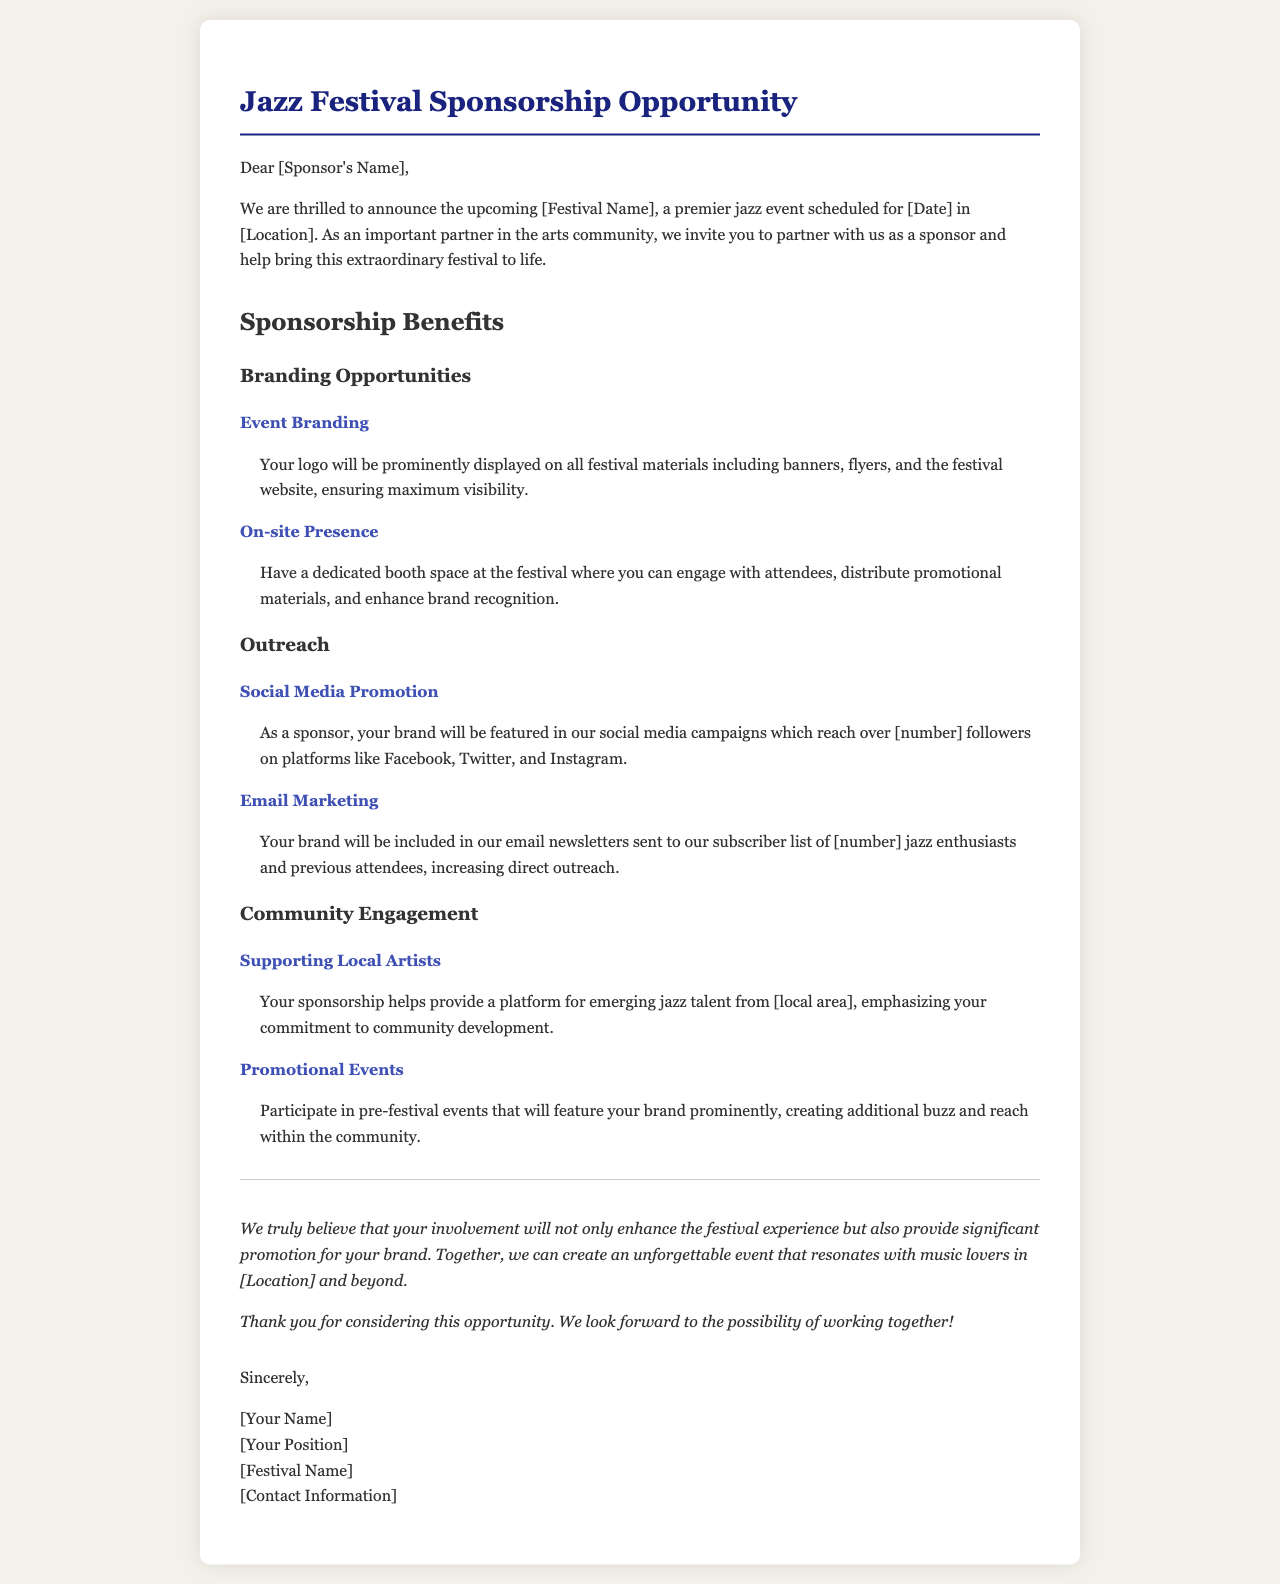What is the title of the document? The title of the document can be found in the header section, which indicates the purpose of the letter.
Answer: Jazz Festival Sponsorship Opportunity What is the date of the festival? The date is mentioned specifically in the opening paragraph inviting sponsorship.
Answer: [Date] What is one benefit of event branding for sponsors? The document outlines various benefits, highlighting how sponsors' logos will be displayed prominently.
Answer: Maximum visibility How many followers are mentioned for social media promotion? This is identified in the outreach section, covering potential audience engagement.
Answer: [number] Which area does the sponsorship support local artists from? The text specifies that the sponsorship focuses on a specific local area to help emerging talent.
Answer: [local area] What type of marketing will include the sponsor's brand? The outreach benefits specify a method where the brand can be showcased.
Answer: Email Marketing What is a suggested activity for community engagement? The document provides examples of how sponsors can engage with the community beyond the main event.
Answer: Promotional Events What is the closing statement's tone? The closing part of the letter presents the intent and invitation for collaboration.
Answer: Positive Who is the letter signed by? The closing signature indicates the author and their position relevant to the festival.
Answer: [Your Name] 